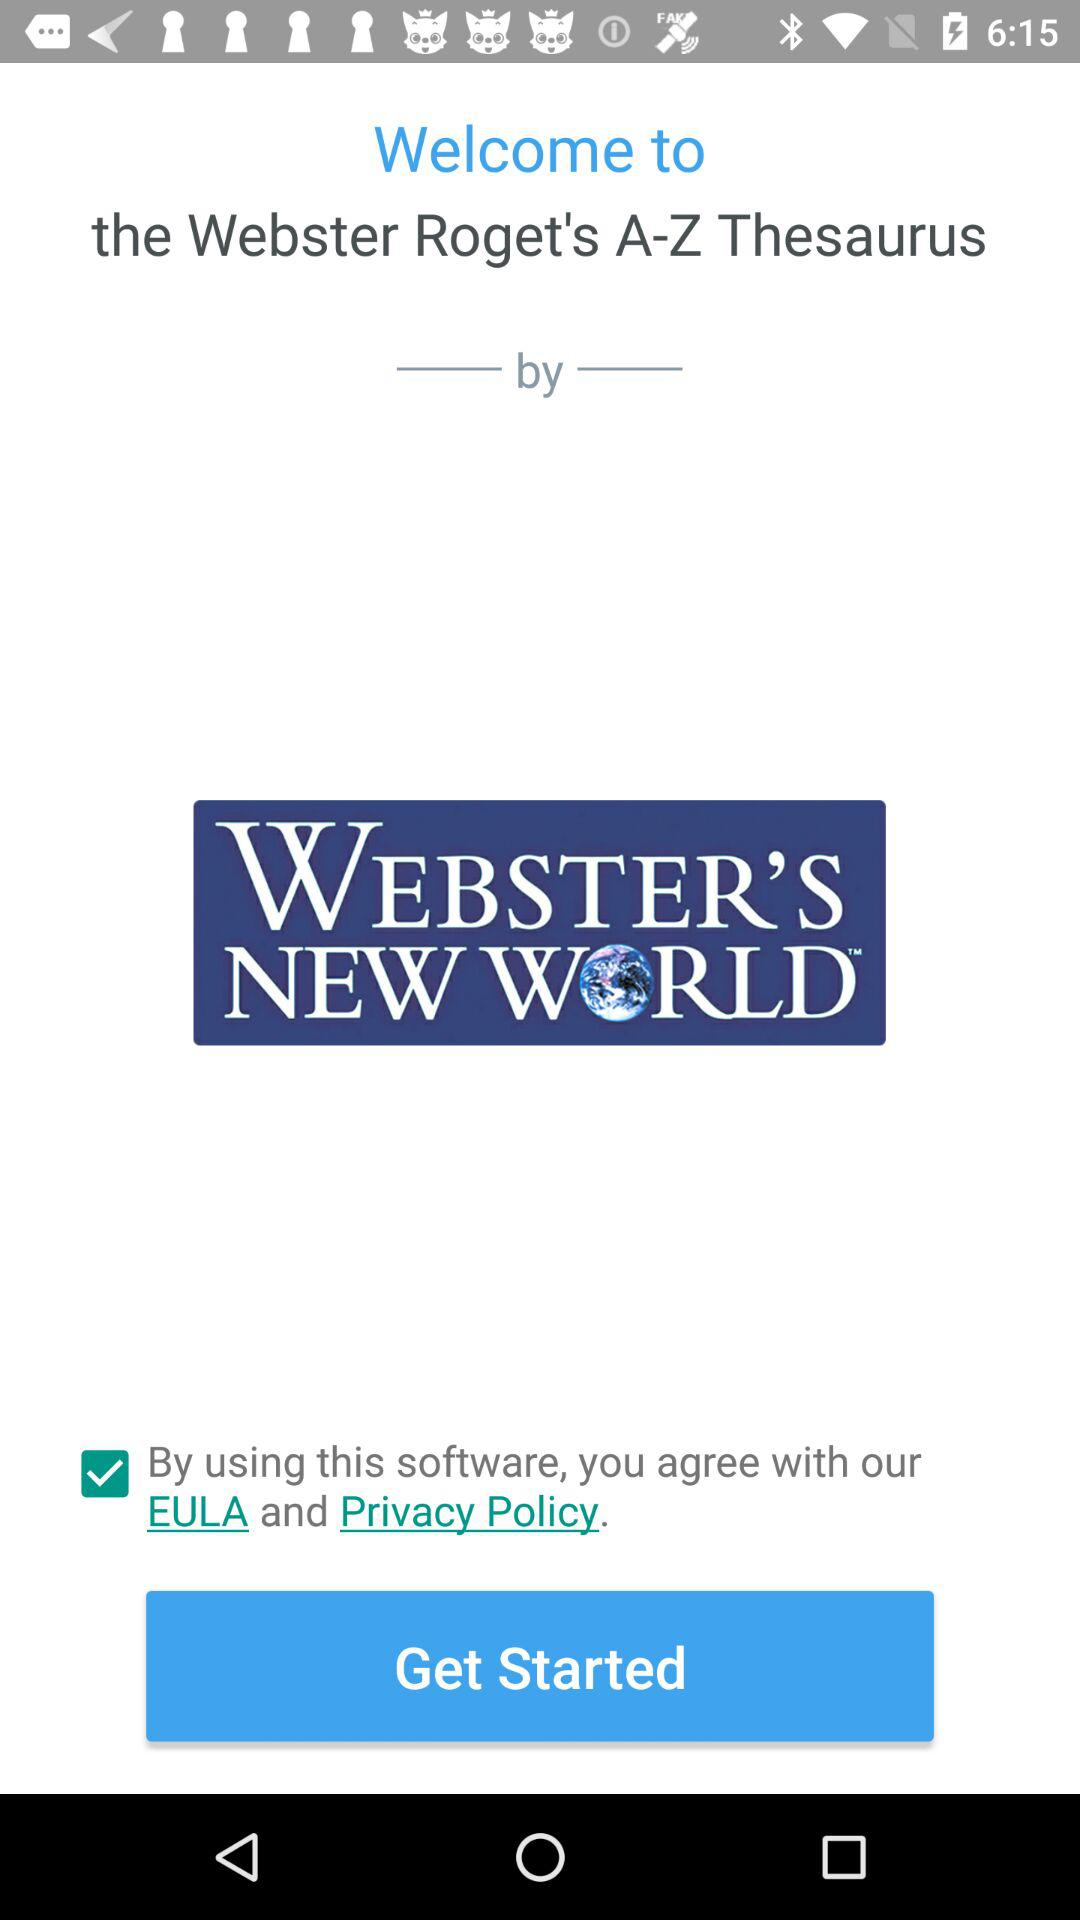What is the name of the application? The name of the application is "WEBSTER'S NEW WORLD". 